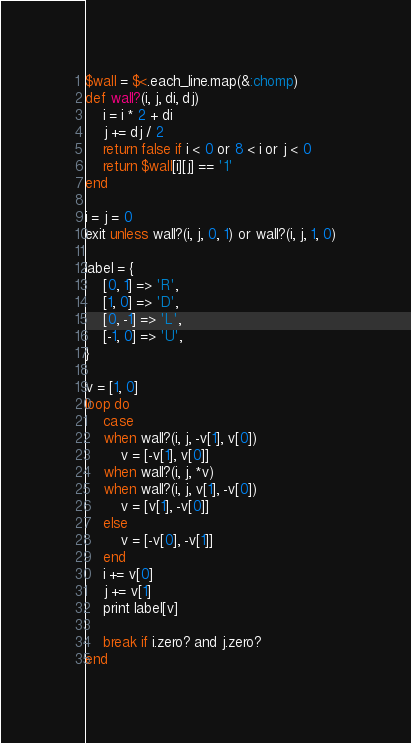<code> <loc_0><loc_0><loc_500><loc_500><_Ruby_>$wall = $<.each_line.map(&:chomp)
def wall?(i, j, di, dj)
	i = i * 2 + di
	j += dj / 2
	return false if i < 0 or 8 < i or j < 0
	return $wall[i][j] == '1'
end

i = j = 0
exit unless wall?(i, j, 0, 1) or wall?(i, j, 1, 0)

label = {
	[0, 1] => 'R',
	[1, 0] => 'D',
	[0, -1] => 'L',
	[-1, 0] => 'U',
}

v = [1, 0]
loop do
	case
	when wall?(i, j, -v[1], v[0])
		v = [-v[1], v[0]]
	when wall?(i, j, *v)
	when wall?(i, j, v[1], -v[0])
		v = [v[1], -v[0]]
	else
		v = [-v[0], -v[1]]
	end
	i += v[0]
	j += v[1]
	print label[v]

	break if i.zero? and j.zero?
end</code> 